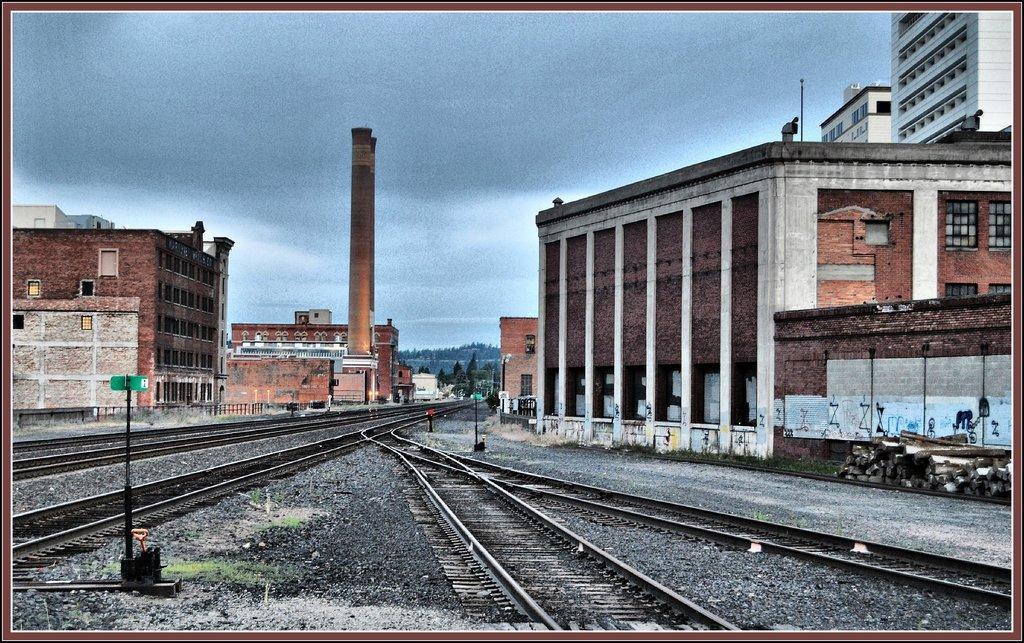Describe this image in one or two sentences. In the picture we can see some railway tracks and in the middle of the tracks we can see stones and we can see some poles and on the either sides of the tracks we can see some buildings and in the background we can see some trees and sky with clouds. 